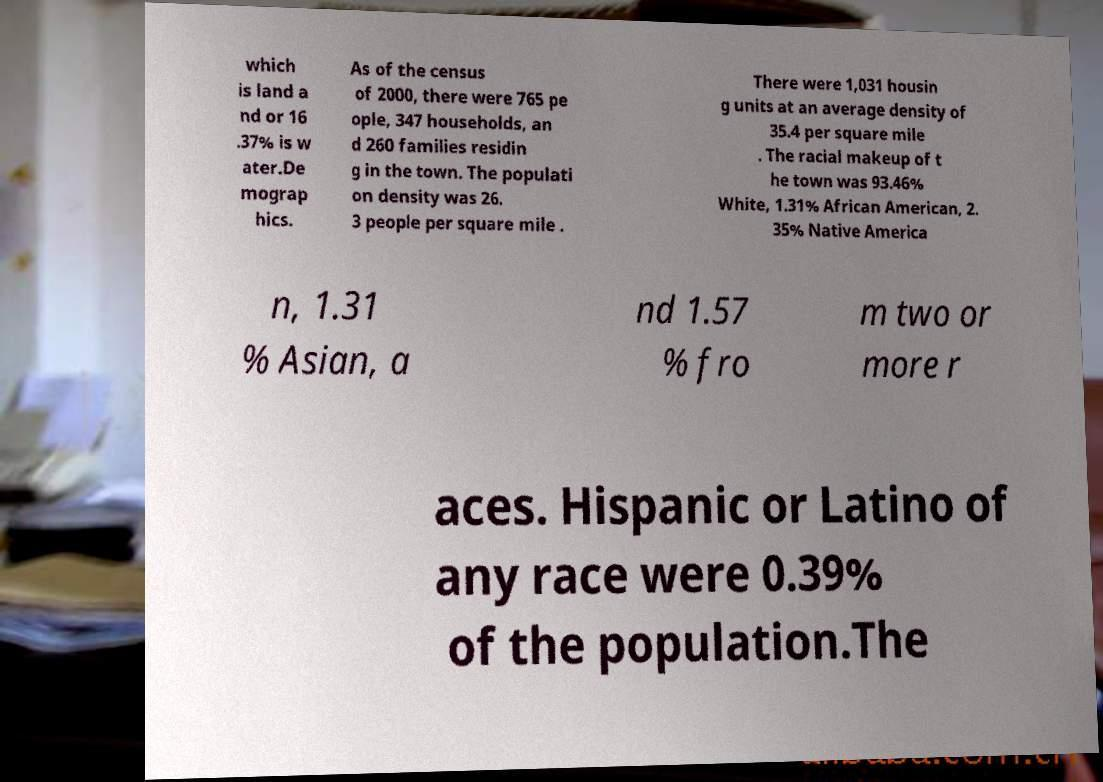I need the written content from this picture converted into text. Can you do that? which is land a nd or 16 .37% is w ater.De mograp hics. As of the census of 2000, there were 765 pe ople, 347 households, an d 260 families residin g in the town. The populati on density was 26. 3 people per square mile . There were 1,031 housin g units at an average density of 35.4 per square mile . The racial makeup of t he town was 93.46% White, 1.31% African American, 2. 35% Native America n, 1.31 % Asian, a nd 1.57 % fro m two or more r aces. Hispanic or Latino of any race were 0.39% of the population.The 